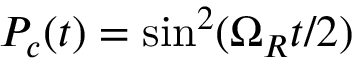<formula> <loc_0><loc_0><loc_500><loc_500>P _ { c } ( t ) = \sin ^ { 2 } ( \Omega _ { R } t / 2 )</formula> 